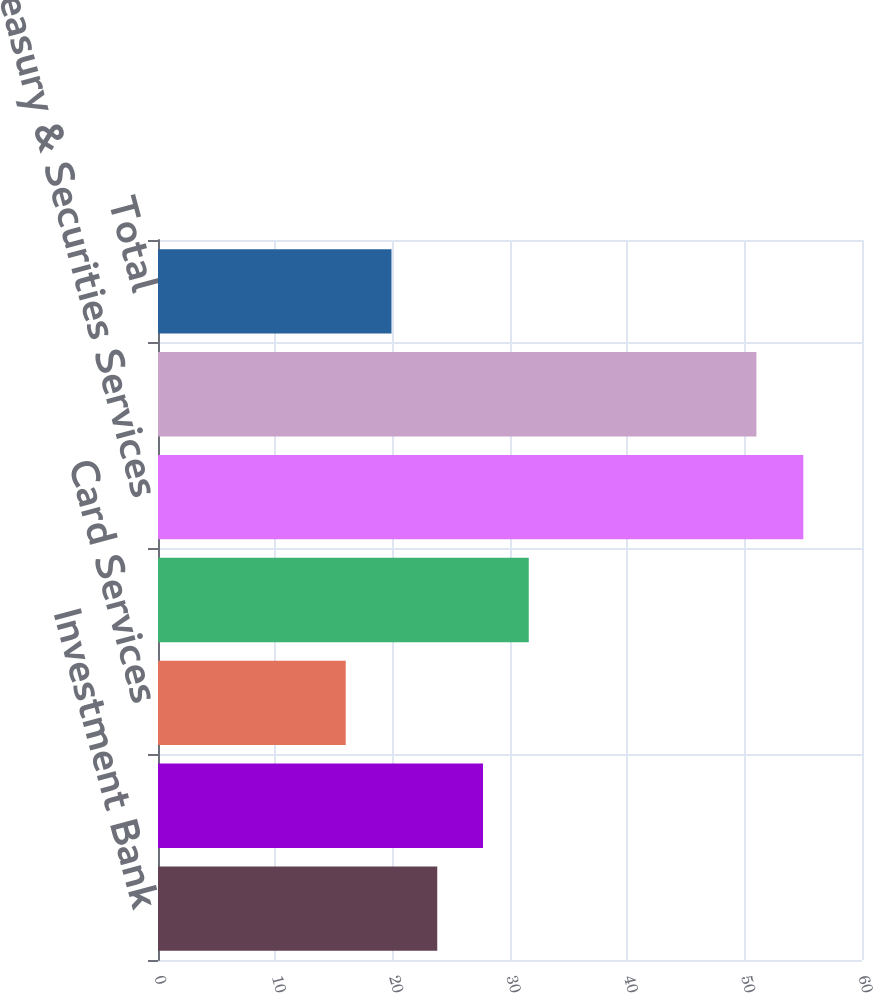<chart> <loc_0><loc_0><loc_500><loc_500><bar_chart><fcel>Investment Bank<fcel>Retail Financial Services<fcel>Card Services<fcel>Commercial Banking<fcel>Treasury & Securities Services<fcel>Asset & Wealth Management<fcel>Total<nl><fcel>23.8<fcel>27.7<fcel>16<fcel>31.6<fcel>55<fcel>51<fcel>19.9<nl></chart> 